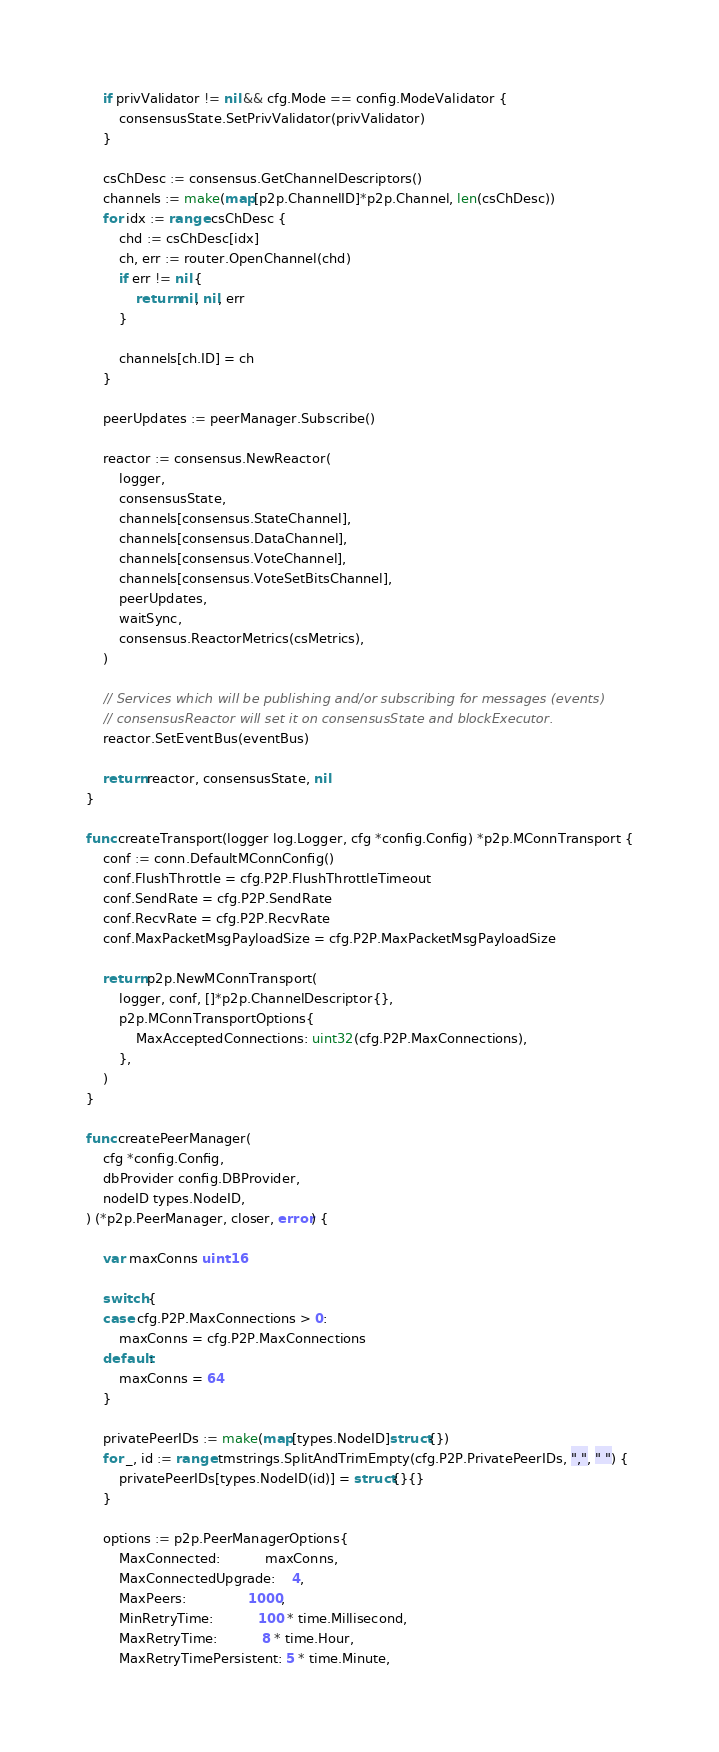<code> <loc_0><loc_0><loc_500><loc_500><_Go_>	if privValidator != nil && cfg.Mode == config.ModeValidator {
		consensusState.SetPrivValidator(privValidator)
	}

	csChDesc := consensus.GetChannelDescriptors()
	channels := make(map[p2p.ChannelID]*p2p.Channel, len(csChDesc))
	for idx := range csChDesc {
		chd := csChDesc[idx]
		ch, err := router.OpenChannel(chd)
		if err != nil {
			return nil, nil, err
		}

		channels[ch.ID] = ch
	}

	peerUpdates := peerManager.Subscribe()

	reactor := consensus.NewReactor(
		logger,
		consensusState,
		channels[consensus.StateChannel],
		channels[consensus.DataChannel],
		channels[consensus.VoteChannel],
		channels[consensus.VoteSetBitsChannel],
		peerUpdates,
		waitSync,
		consensus.ReactorMetrics(csMetrics),
	)

	// Services which will be publishing and/or subscribing for messages (events)
	// consensusReactor will set it on consensusState and blockExecutor.
	reactor.SetEventBus(eventBus)

	return reactor, consensusState, nil
}

func createTransport(logger log.Logger, cfg *config.Config) *p2p.MConnTransport {
	conf := conn.DefaultMConnConfig()
	conf.FlushThrottle = cfg.P2P.FlushThrottleTimeout
	conf.SendRate = cfg.P2P.SendRate
	conf.RecvRate = cfg.P2P.RecvRate
	conf.MaxPacketMsgPayloadSize = cfg.P2P.MaxPacketMsgPayloadSize

	return p2p.NewMConnTransport(
		logger, conf, []*p2p.ChannelDescriptor{},
		p2p.MConnTransportOptions{
			MaxAcceptedConnections: uint32(cfg.P2P.MaxConnections),
		},
	)
}

func createPeerManager(
	cfg *config.Config,
	dbProvider config.DBProvider,
	nodeID types.NodeID,
) (*p2p.PeerManager, closer, error) {

	var maxConns uint16

	switch {
	case cfg.P2P.MaxConnections > 0:
		maxConns = cfg.P2P.MaxConnections
	default:
		maxConns = 64
	}

	privatePeerIDs := make(map[types.NodeID]struct{})
	for _, id := range tmstrings.SplitAndTrimEmpty(cfg.P2P.PrivatePeerIDs, ",", " ") {
		privatePeerIDs[types.NodeID(id)] = struct{}{}
	}

	options := p2p.PeerManagerOptions{
		MaxConnected:           maxConns,
		MaxConnectedUpgrade:    4,
		MaxPeers:               1000,
		MinRetryTime:           100 * time.Millisecond,
		MaxRetryTime:           8 * time.Hour,
		MaxRetryTimePersistent: 5 * time.Minute,</code> 